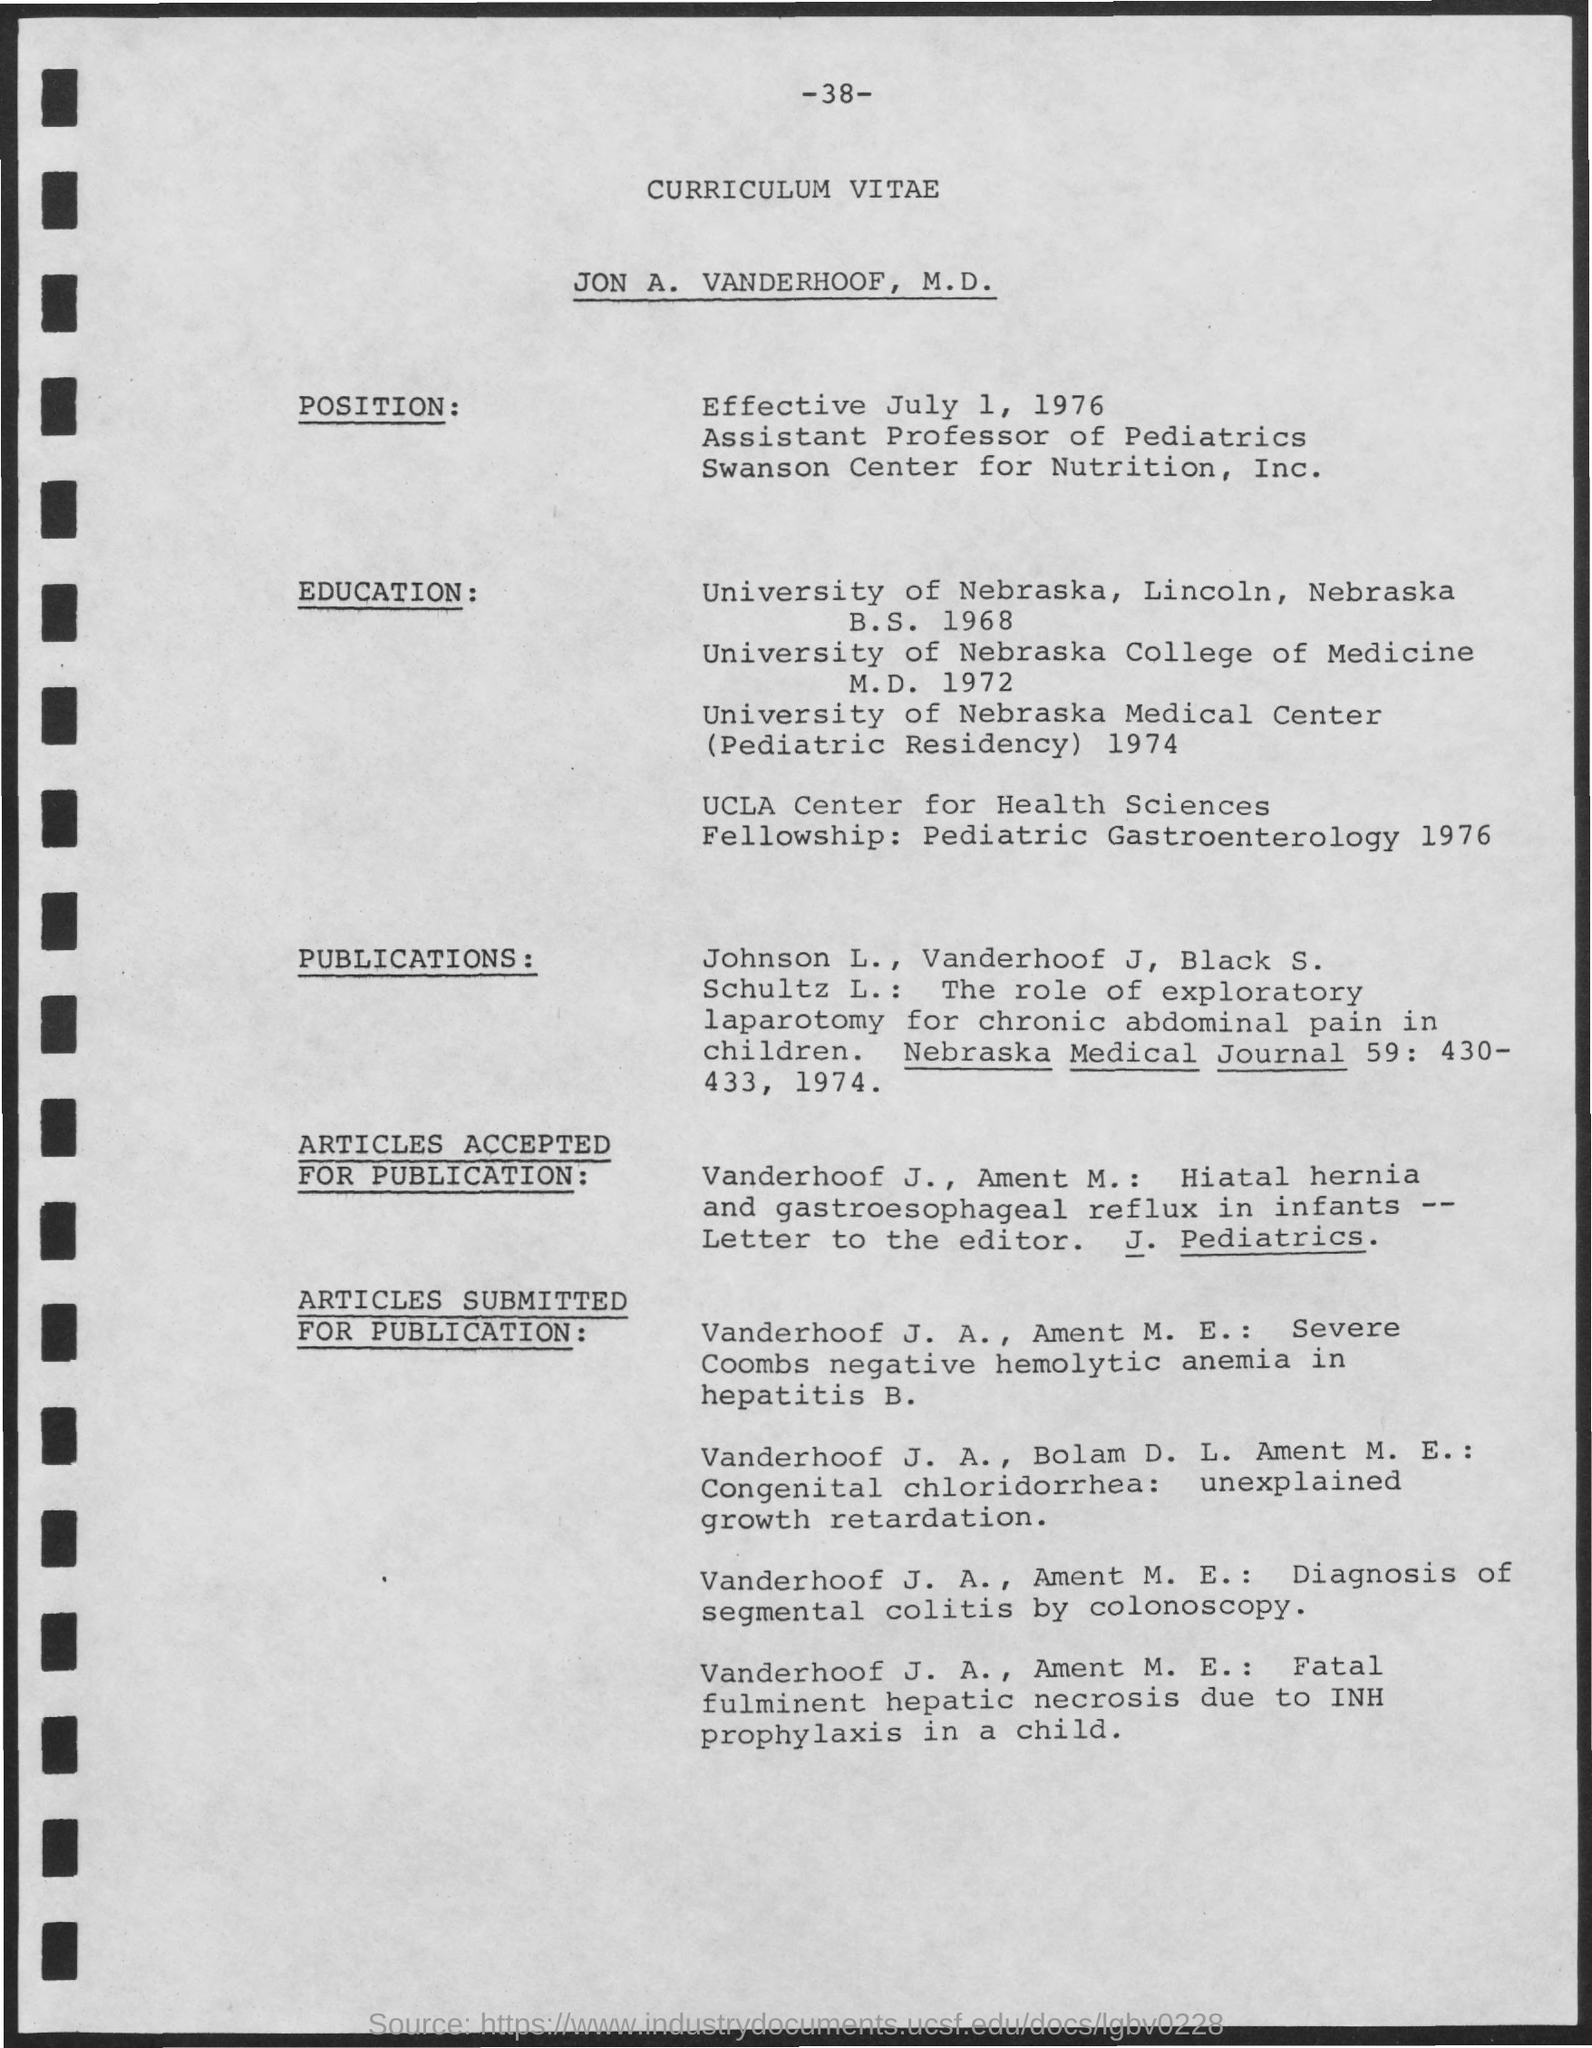What type of documentation is this?
Give a very brief answer. CURRICULUM VITAE. Whose curriculum vitae is this?
Your answer should be very brief. Jon a. vanderhoof, m.d. What is Jon's position?
Your response must be concise. Assistant professor of pediatrics. When is the position effective from?
Your response must be concise. July 1, 1976. In which journal has Jon's paper been published?
Your answer should be very brief. Nebraska Medical Journal. 